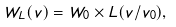<formula> <loc_0><loc_0><loc_500><loc_500>W _ { L } ( v ) = W _ { 0 } \times L ( v / v _ { 0 } ) ,</formula> 